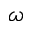<formula> <loc_0><loc_0><loc_500><loc_500>\omega</formula> 